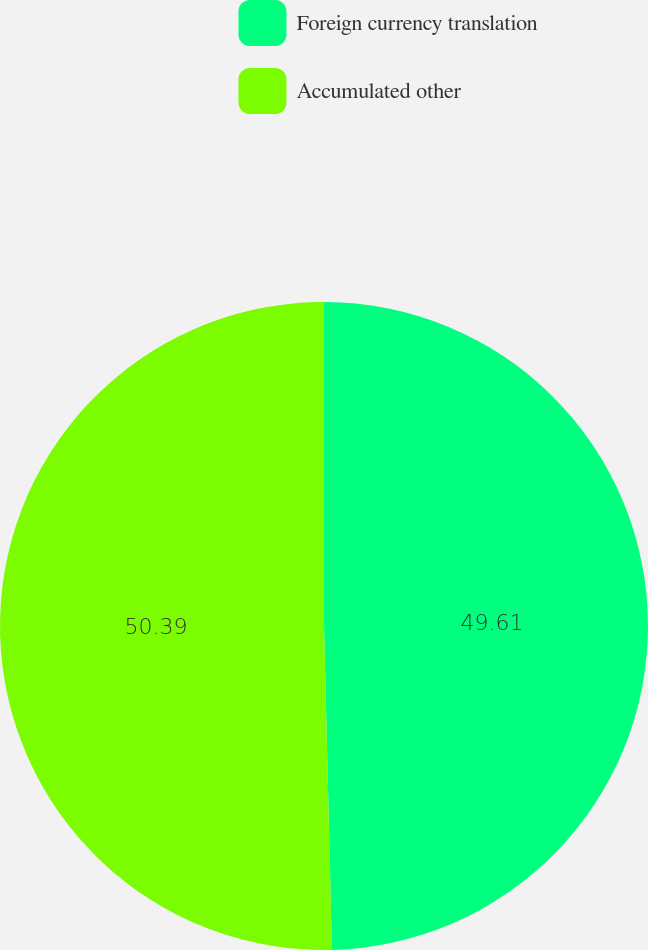<chart> <loc_0><loc_0><loc_500><loc_500><pie_chart><fcel>Foreign currency translation<fcel>Accumulated other<nl><fcel>49.61%<fcel>50.39%<nl></chart> 